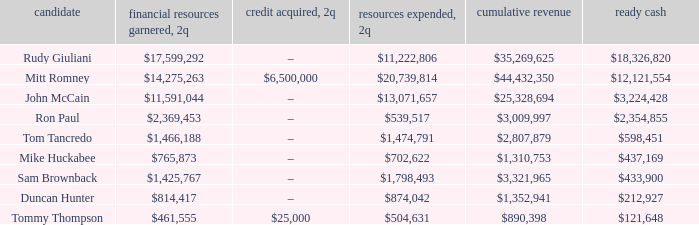Tell me the total receipts for tom tancredo $2,807,879. 